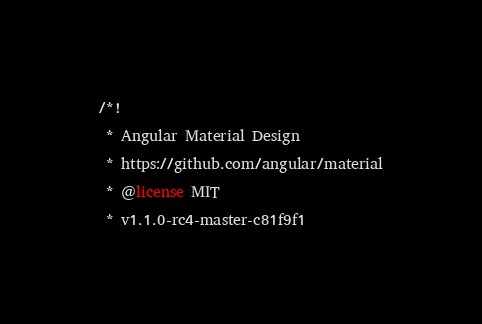<code> <loc_0><loc_0><loc_500><loc_500><_CSS_>/*!
 * Angular Material Design
 * https://github.com/angular/material
 * @license MIT
 * v1.1.0-rc4-master-c81f9f1</code> 